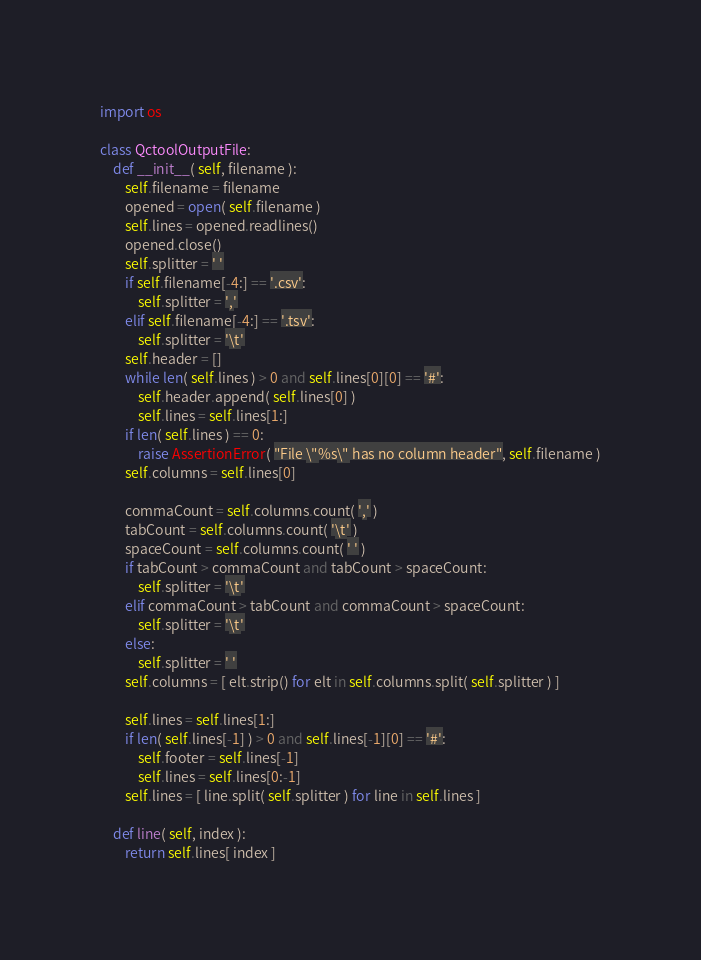<code> <loc_0><loc_0><loc_500><loc_500><_Python_>import os

class QctoolOutputFile:
	def __init__( self, filename ):
		self.filename = filename
		opened = open( self.filename )
		self.lines = opened.readlines()
		opened.close()
		self.splitter = ' '
		if self.filename[-4:] == '.csv':
			self.splitter = ','
		elif self.filename[-4:] == '.tsv':
			self.splitter = '\t'
		self.header = []
		while len( self.lines ) > 0 and self.lines[0][0] == '#':
			self.header.append( self.lines[0] )
			self.lines = self.lines[1:]
		if len( self.lines ) == 0:
			raise AssertionError( "File \"%s\" has no column header", self.filename )
		self.columns = self.lines[0]

		commaCount = self.columns.count( ',' )
		tabCount = self.columns.count( '\t' )
		spaceCount = self.columns.count( ' ' )
		if tabCount > commaCount and tabCount > spaceCount:
			self.splitter = '\t'
		elif commaCount > tabCount and commaCount > spaceCount:
			self.splitter = '\t'
		else:
			self.splitter = ' '
		self.columns = [ elt.strip() for elt in self.columns.split( self.splitter ) ]

		self.lines = self.lines[1:]
		if len( self.lines[-1] ) > 0 and self.lines[-1][0] == '#':
			self.footer = self.lines[-1]
			self.lines = self.lines[0:-1]
		self.lines = [ line.split( self.splitter ) for line in self.lines ]
	
	def line( self, index ):
		return self.lines[ index ]
</code> 